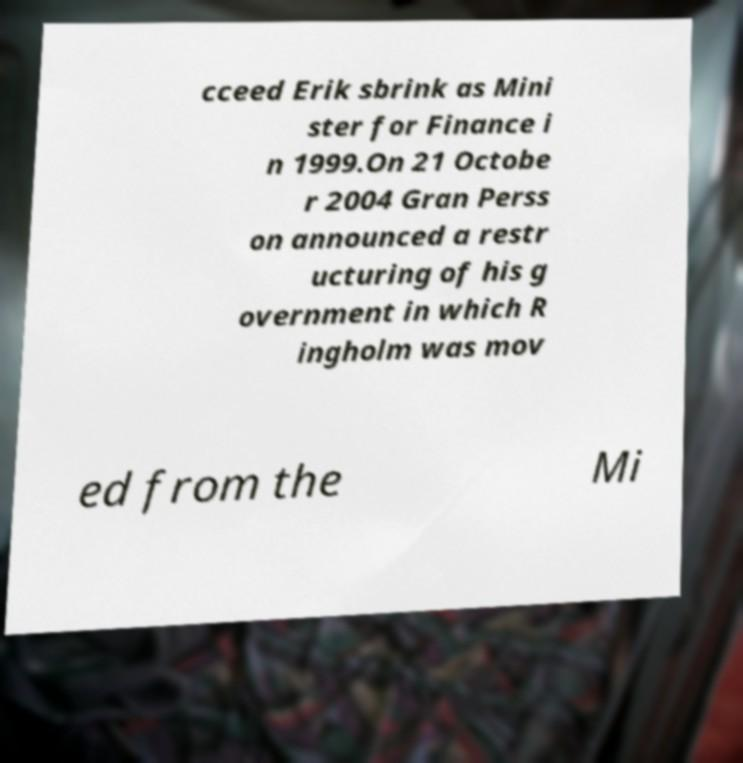Please read and relay the text visible in this image. What does it say? cceed Erik sbrink as Mini ster for Finance i n 1999.On 21 Octobe r 2004 Gran Perss on announced a restr ucturing of his g overnment in which R ingholm was mov ed from the Mi 